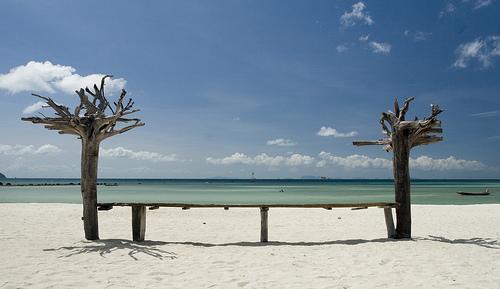How many dead trees are there?
Give a very brief answer. 2. 